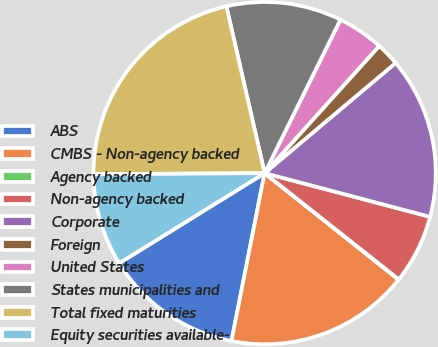<chart> <loc_0><loc_0><loc_500><loc_500><pie_chart><fcel>ABS<fcel>CMBS - Non-agency backed<fcel>Agency backed<fcel>Non-agency backed<fcel>Corporate<fcel>Foreign<fcel>United States<fcel>States municipalities and<fcel>Total fixed maturities<fcel>Equity securities available-<nl><fcel>13.07%<fcel>17.41%<fcel>0.03%<fcel>6.55%<fcel>15.24%<fcel>2.2%<fcel>4.37%<fcel>10.89%<fcel>21.52%<fcel>8.72%<nl></chart> 